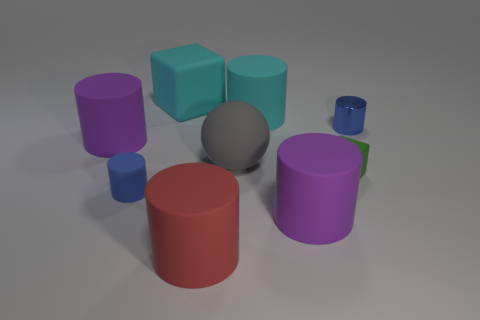Subtract all metal cylinders. How many cylinders are left? 5 Subtract all cyan cylinders. How many cylinders are left? 5 Subtract all green cylinders. Subtract all gray blocks. How many cylinders are left? 6 Add 1 purple rubber things. How many objects exist? 10 Subtract all cylinders. How many objects are left? 3 Subtract 0 brown cubes. How many objects are left? 9 Subtract all matte cylinders. Subtract all large cubes. How many objects are left? 3 Add 1 green matte objects. How many green matte objects are left? 2 Add 7 tiny blue rubber cylinders. How many tiny blue rubber cylinders exist? 8 